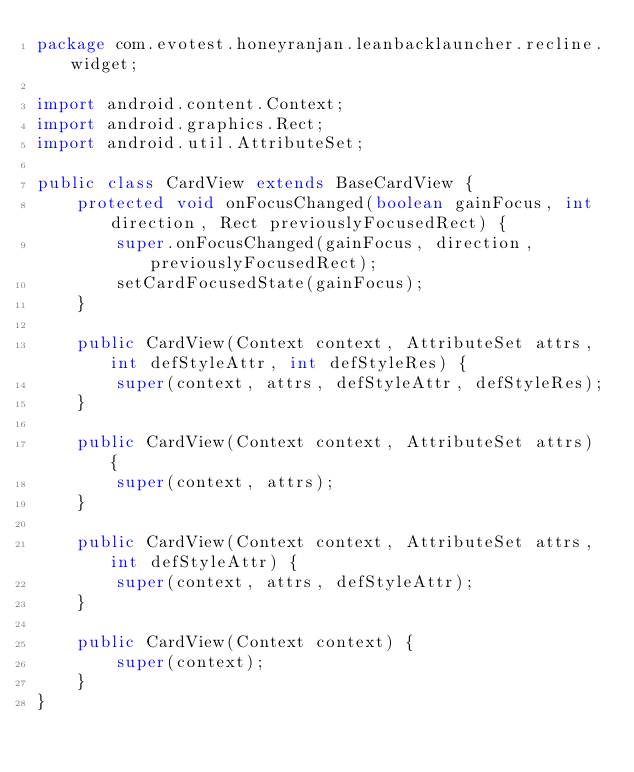Convert code to text. <code><loc_0><loc_0><loc_500><loc_500><_Java_>package com.evotest.honeyranjan.leanbacklauncher.recline.widget;

import android.content.Context;
import android.graphics.Rect;
import android.util.AttributeSet;

public class CardView extends BaseCardView {
    protected void onFocusChanged(boolean gainFocus, int direction, Rect previouslyFocusedRect) {
        super.onFocusChanged(gainFocus, direction, previouslyFocusedRect);
        setCardFocusedState(gainFocus);
    }

    public CardView(Context context, AttributeSet attrs, int defStyleAttr, int defStyleRes) {
        super(context, attrs, defStyleAttr, defStyleRes);
    }

    public CardView(Context context, AttributeSet attrs) {
        super(context, attrs);
    }

    public CardView(Context context, AttributeSet attrs, int defStyleAttr) {
        super(context, attrs, defStyleAttr);
    }

    public CardView(Context context) {
        super(context);
    }
}
</code> 